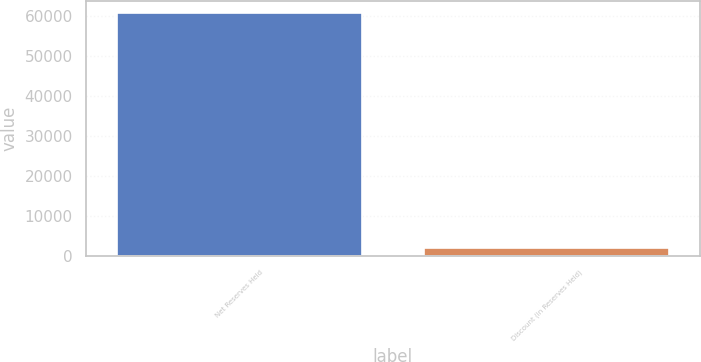Convert chart to OTSL. <chart><loc_0><loc_0><loc_500><loc_500><bar_chart><fcel>Net Reserves Held<fcel>Discount (in Reserves Held)<nl><fcel>60749.7<fcel>2110<nl></chart> 